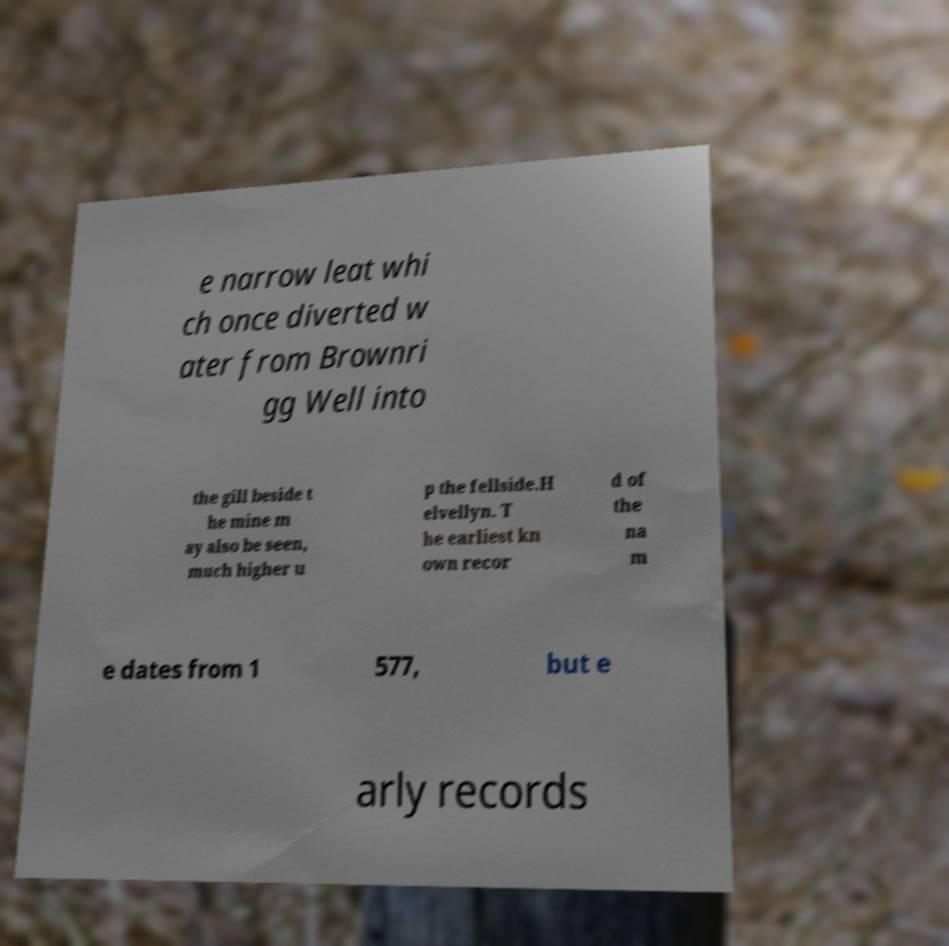Please read and relay the text visible in this image. What does it say? e narrow leat whi ch once diverted w ater from Brownri gg Well into the gill beside t he mine m ay also be seen, much higher u p the fellside.H elvellyn. T he earliest kn own recor d of the na m e dates from 1 577, but e arly records 